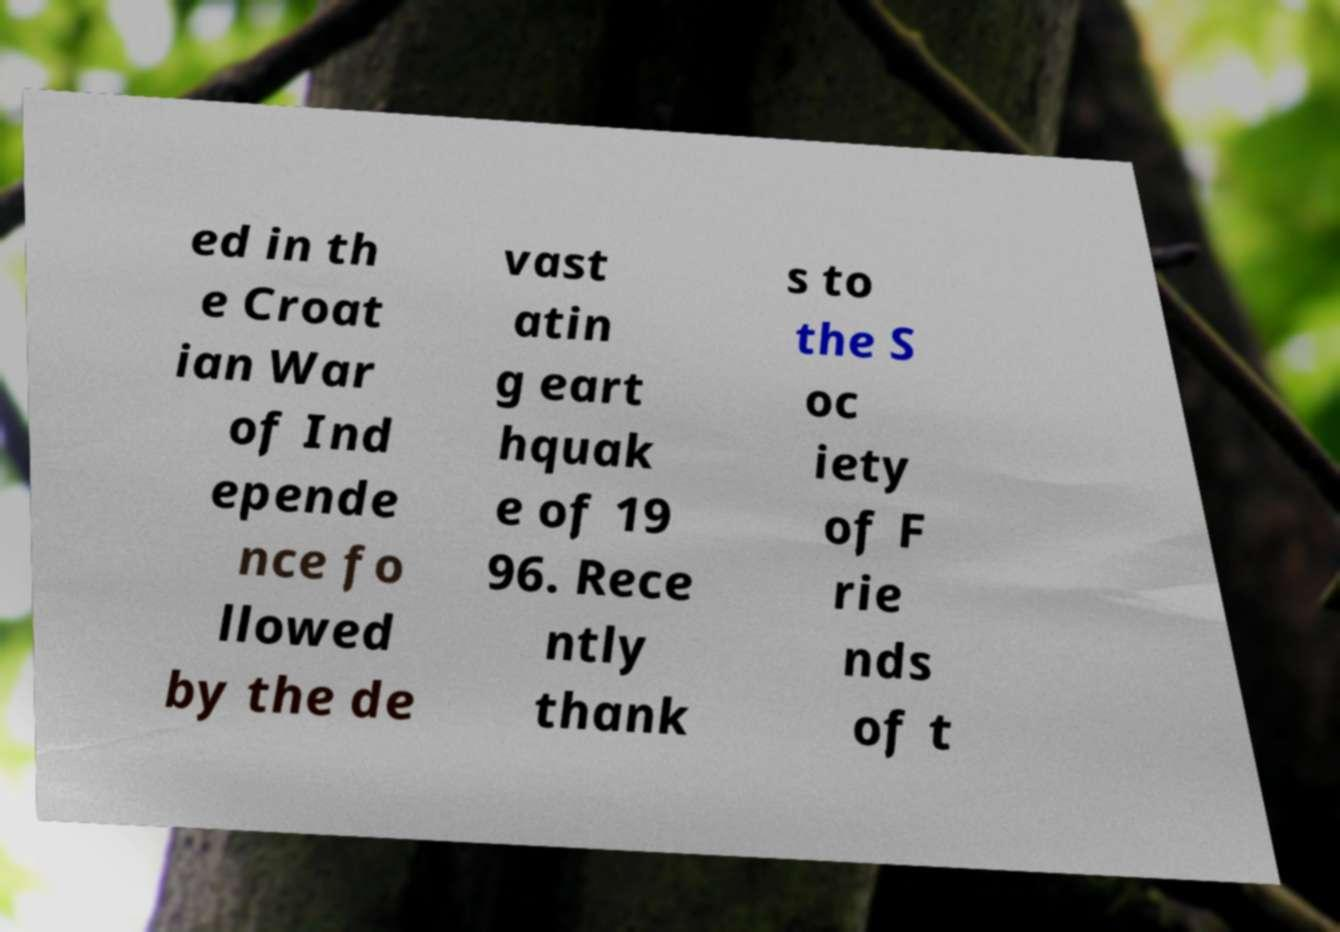Could you extract and type out the text from this image? ed in th e Croat ian War of Ind epende nce fo llowed by the de vast atin g eart hquak e of 19 96. Rece ntly thank s to the S oc iety of F rie nds of t 